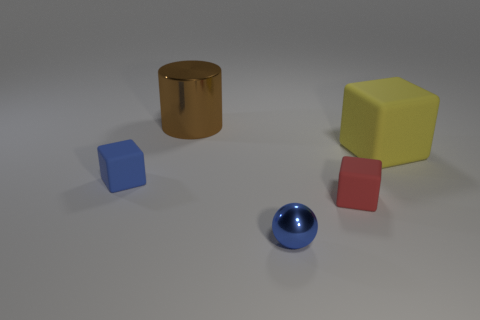What number of things are both to the left of the large brown shiny cylinder and to the right of the big brown cylinder?
Your answer should be compact. 0. What is the shape of the thing that is on the left side of the brown object?
Offer a very short reply. Cube. How many other green balls are made of the same material as the ball?
Your response must be concise. 0. There is a tiny red object; is it the same shape as the small blue object to the left of the blue metallic object?
Ensure brevity in your answer.  Yes. Are there any brown things that are right of the small rubber object right of the blue thing behind the tiny shiny sphere?
Your answer should be compact. No. What size is the rubber cube that is behind the small blue rubber cube?
Your answer should be compact. Large. There is a block that is the same size as the shiny cylinder; what is its material?
Offer a terse response. Rubber. Is the shape of the tiny red matte thing the same as the large yellow rubber object?
Make the answer very short. Yes. What number of things are brown metal objects or cubes in front of the large yellow object?
Give a very brief answer. 3. There is a metal object that is in front of the yellow block; does it have the same size as the red rubber block?
Provide a short and direct response. Yes. 